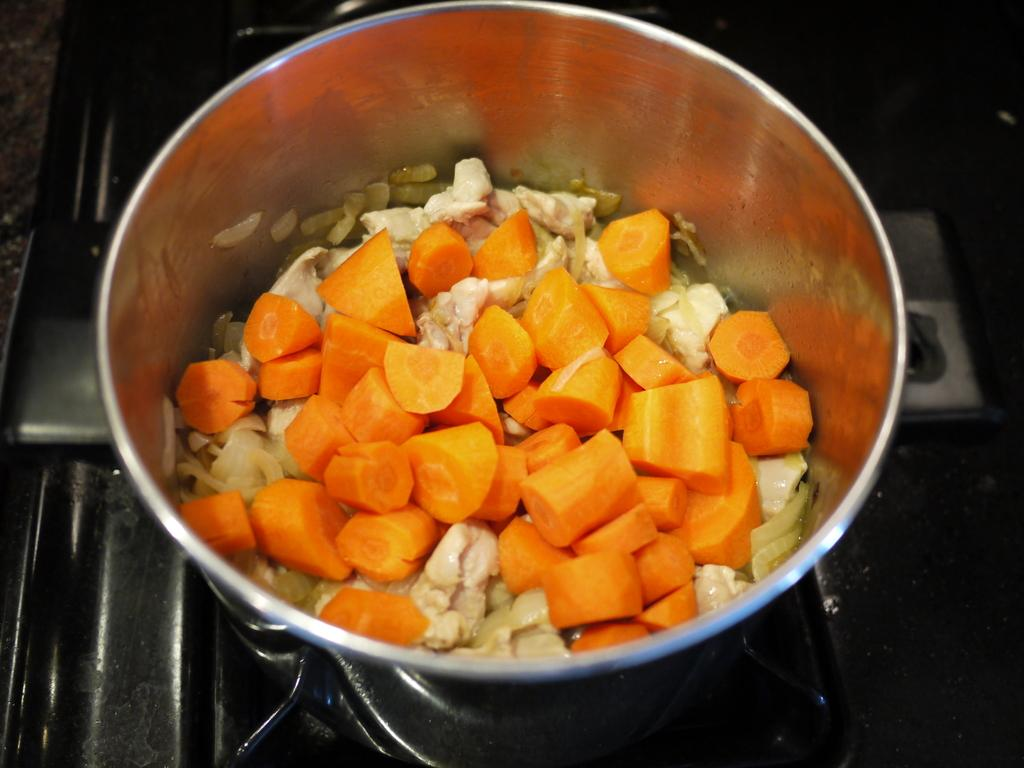What is in the bowl that is visible in the image? There is a bowl with vegetables in it. Where is the bowl located in the image? The bowl is on a stove. What type of berry can be seen sneezing in the image? There is no berry present in the image, and berries do not have the ability to sneeze. 